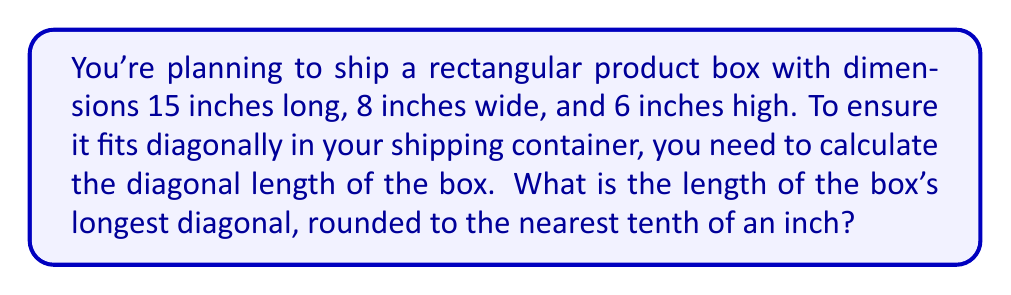Can you answer this question? To solve this problem, we'll use the three-dimensional version of the Pythagorean theorem, also known as the distance formula in 3D space.

Let's denote:
$l$ = length = 15 inches
$w$ = width = 8 inches
$h$ = height = 6 inches

The formula for the diagonal length $d$ is:

$$d = \sqrt{l^2 + w^2 + h^2}$$

Step 1: Substitute the values into the formula:
$$d = \sqrt{15^2 + 8^2 + 6^2}$$

Step 2: Calculate the squares:
$$d = \sqrt{225 + 64 + 36}$$

Step 3: Sum the values under the square root:
$$d = \sqrt{325}$$

Step 4: Calculate the square root:
$$d \approx 18.0277563773...$$

Step 5: Round to the nearest tenth:
$$d \approx 18.0\text{ inches}$$

This diagonal length is crucial for determining the minimum size of shipping containers and for providing accurate shipping estimates to your customers.
Answer: 18.0 inches 